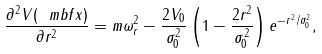Convert formula to latex. <formula><loc_0><loc_0><loc_500><loc_500>\frac { \partial ^ { 2 } V ( \ m b f { x } ) } { \partial r ^ { 2 } } = m \omega _ { r } ^ { 2 } - \frac { 2 V _ { 0 } } { \sigma _ { 0 } ^ { 2 } } \left ( 1 - \frac { 2 r ^ { 2 } } { \sigma _ { 0 } ^ { 2 } } \right ) e ^ { - r ^ { 2 } / \sigma _ { 0 } ^ { 2 } } ,</formula> 